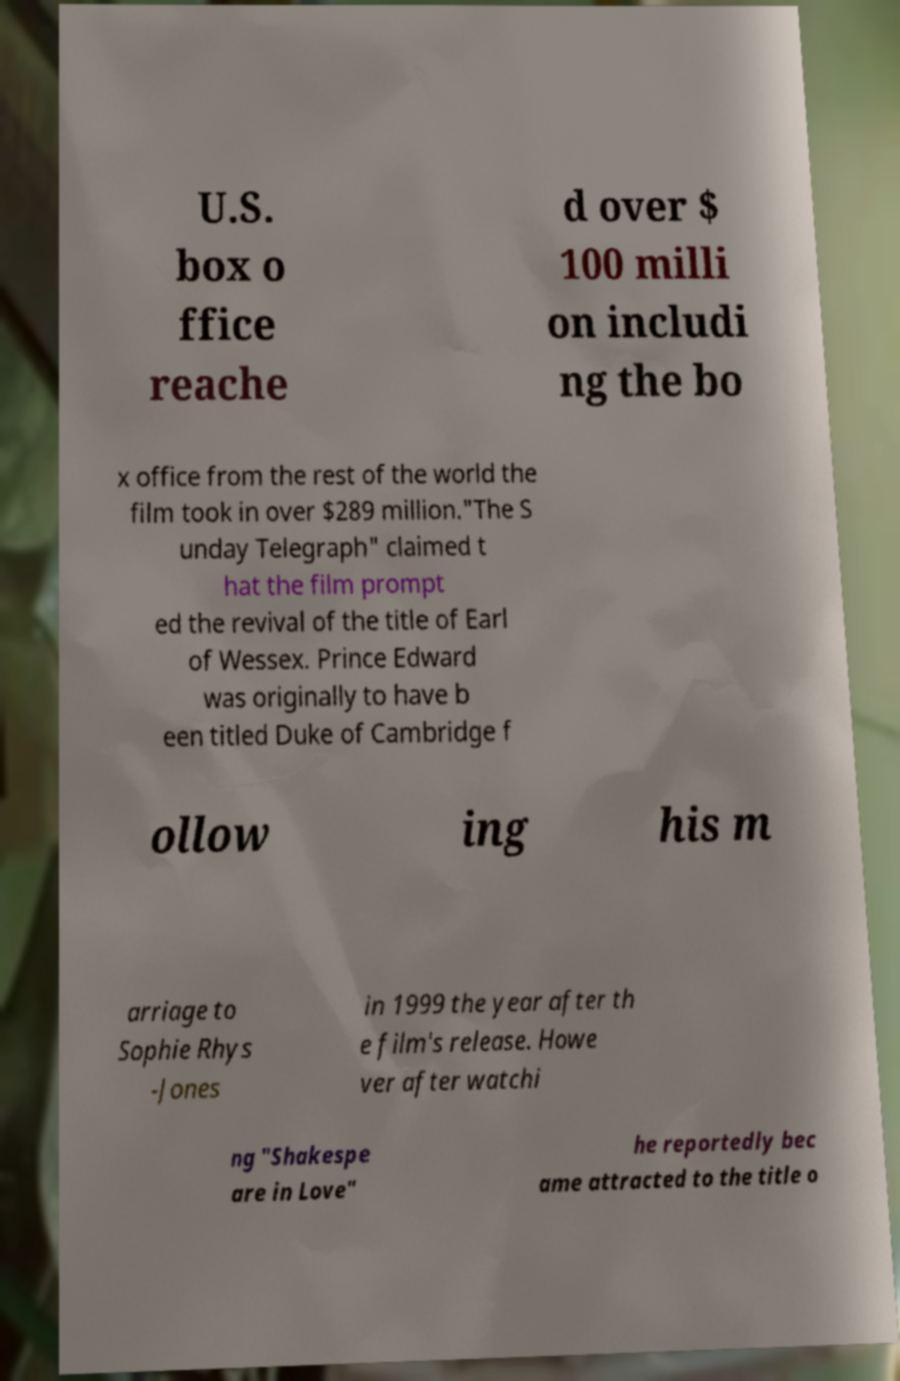Can you read and provide the text displayed in the image?This photo seems to have some interesting text. Can you extract and type it out for me? U.S. box o ffice reache d over $ 100 milli on includi ng the bo x office from the rest of the world the film took in over $289 million."The S unday Telegraph" claimed t hat the film prompt ed the revival of the title of Earl of Wessex. Prince Edward was originally to have b een titled Duke of Cambridge f ollow ing his m arriage to Sophie Rhys -Jones in 1999 the year after th e film's release. Howe ver after watchi ng "Shakespe are in Love" he reportedly bec ame attracted to the title o 